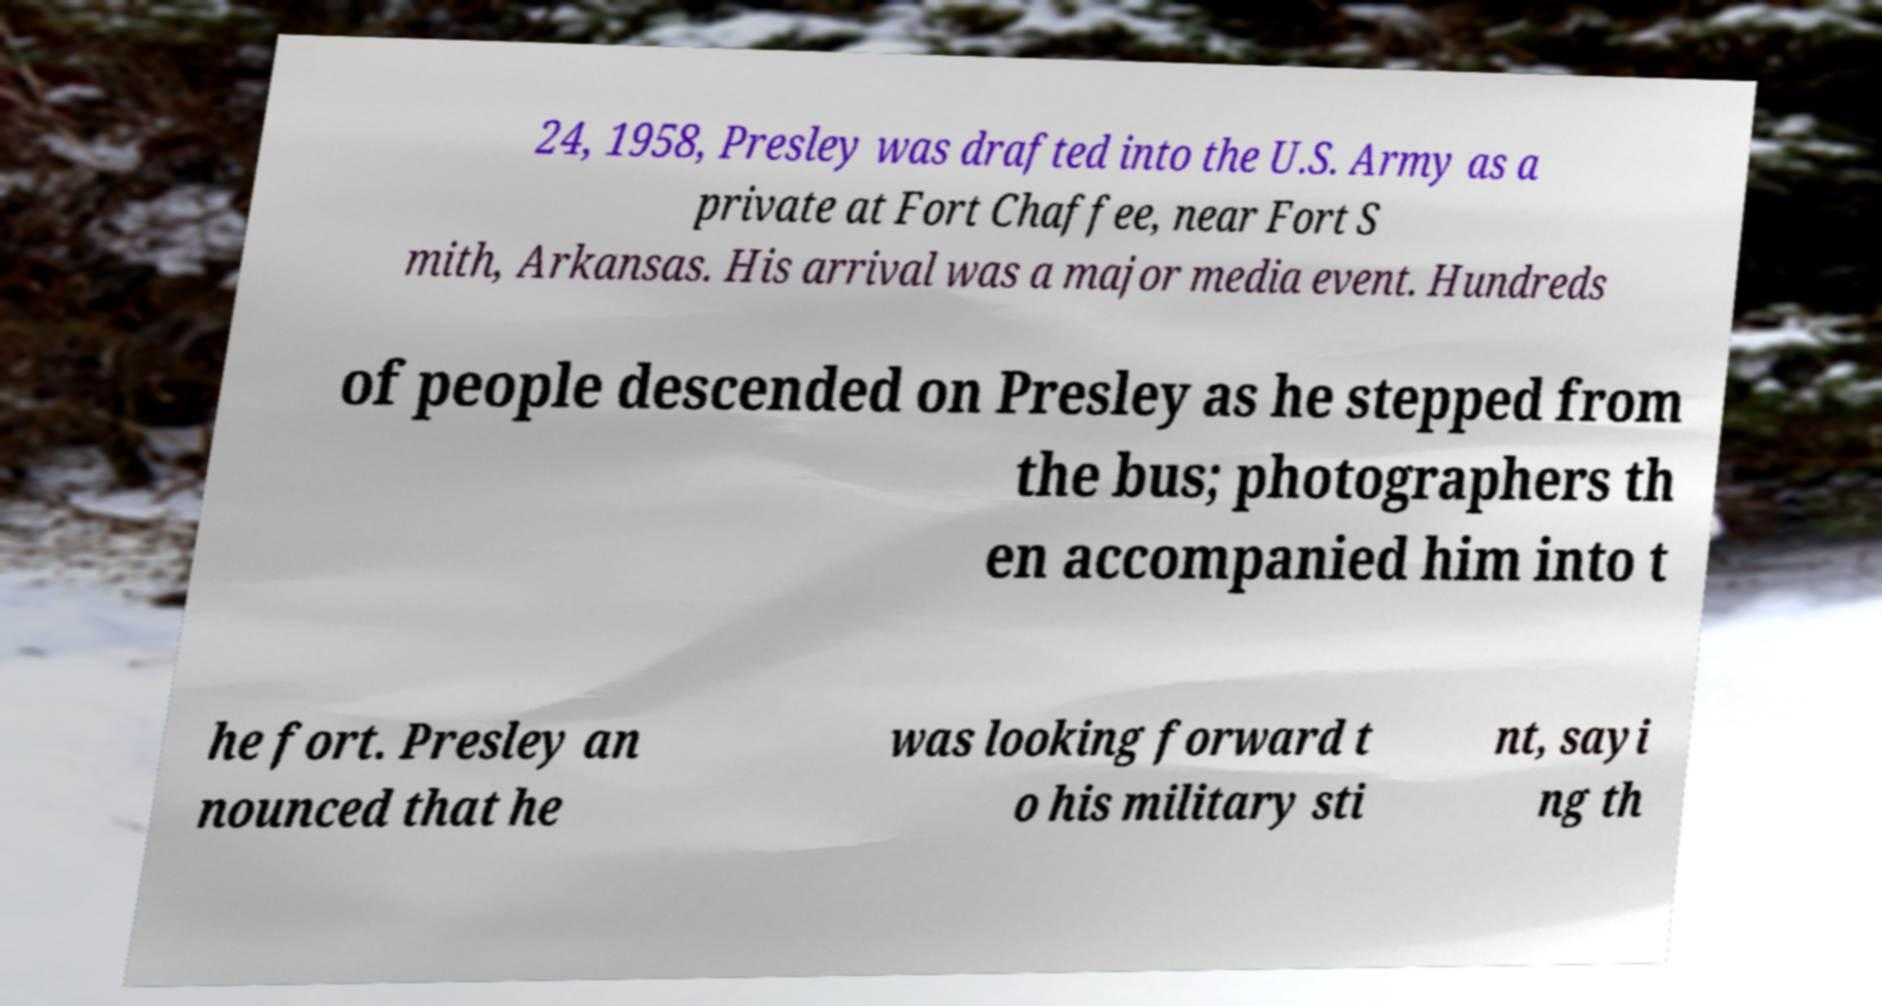There's text embedded in this image that I need extracted. Can you transcribe it verbatim? 24, 1958, Presley was drafted into the U.S. Army as a private at Fort Chaffee, near Fort S mith, Arkansas. His arrival was a major media event. Hundreds of people descended on Presley as he stepped from the bus; photographers th en accompanied him into t he fort. Presley an nounced that he was looking forward t o his military sti nt, sayi ng th 